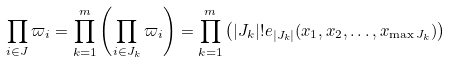<formula> <loc_0><loc_0><loc_500><loc_500>\prod _ { i \in J } \varpi _ { i } = \prod _ { k = 1 } ^ { m } \left ( \prod _ { i \in J _ { k } } \varpi _ { i } \right ) = \prod _ { k = 1 } ^ { m } \left ( | J _ { k } | ! e _ { | J _ { k } | } ( x _ { 1 } , x _ { 2 } , \dots , x _ { \max J _ { k } } ) \right )</formula> 